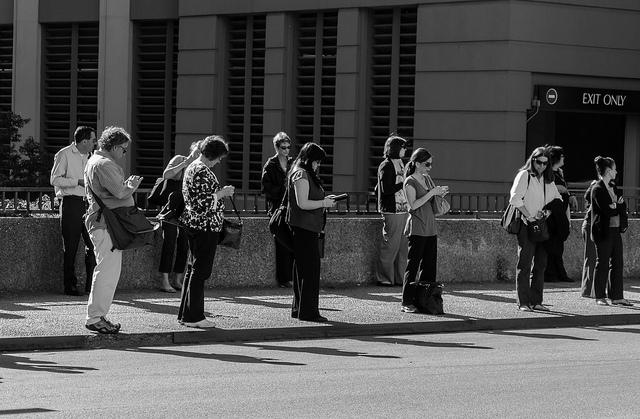Is this a tennis team?
Give a very brief answer. No. What are the men videotaping?
Be succinct. Nothing. What does the sign say?
Keep it brief. Exit only. Is this image old?
Short answer required. No. Are they dancing?
Give a very brief answer. No. How many people are wearing messenger bags across their chests?
Short answer required. 0. Is the floor pattern?
Quick response, please. No. Are these people trying to cross the road?
Keep it brief. No. Are they at a disco?
Be succinct. No. What is the woman holding?
Be succinct. Phone. Is the photo colorful?
Quick response, please. No. What style of pants is the woman in the center wearing?
Quick response, please. Jeans. Whose office are they outside of?
Concise answer only. Bank. Are these people having a good time?
Answer briefly. No. Is this a playground?
Keep it brief. No. 